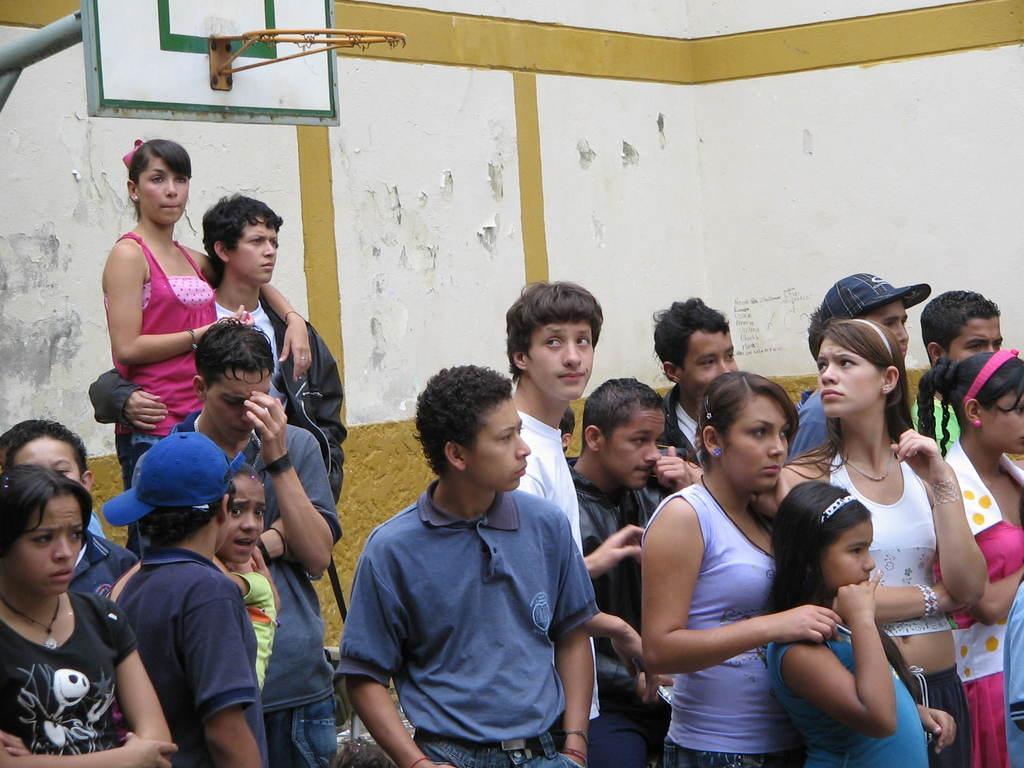Can you describe this image briefly? In this image we can see a group of people standing. In that we can see a man and a woman holding each other. On the backside we can see a goal post and a wall. 